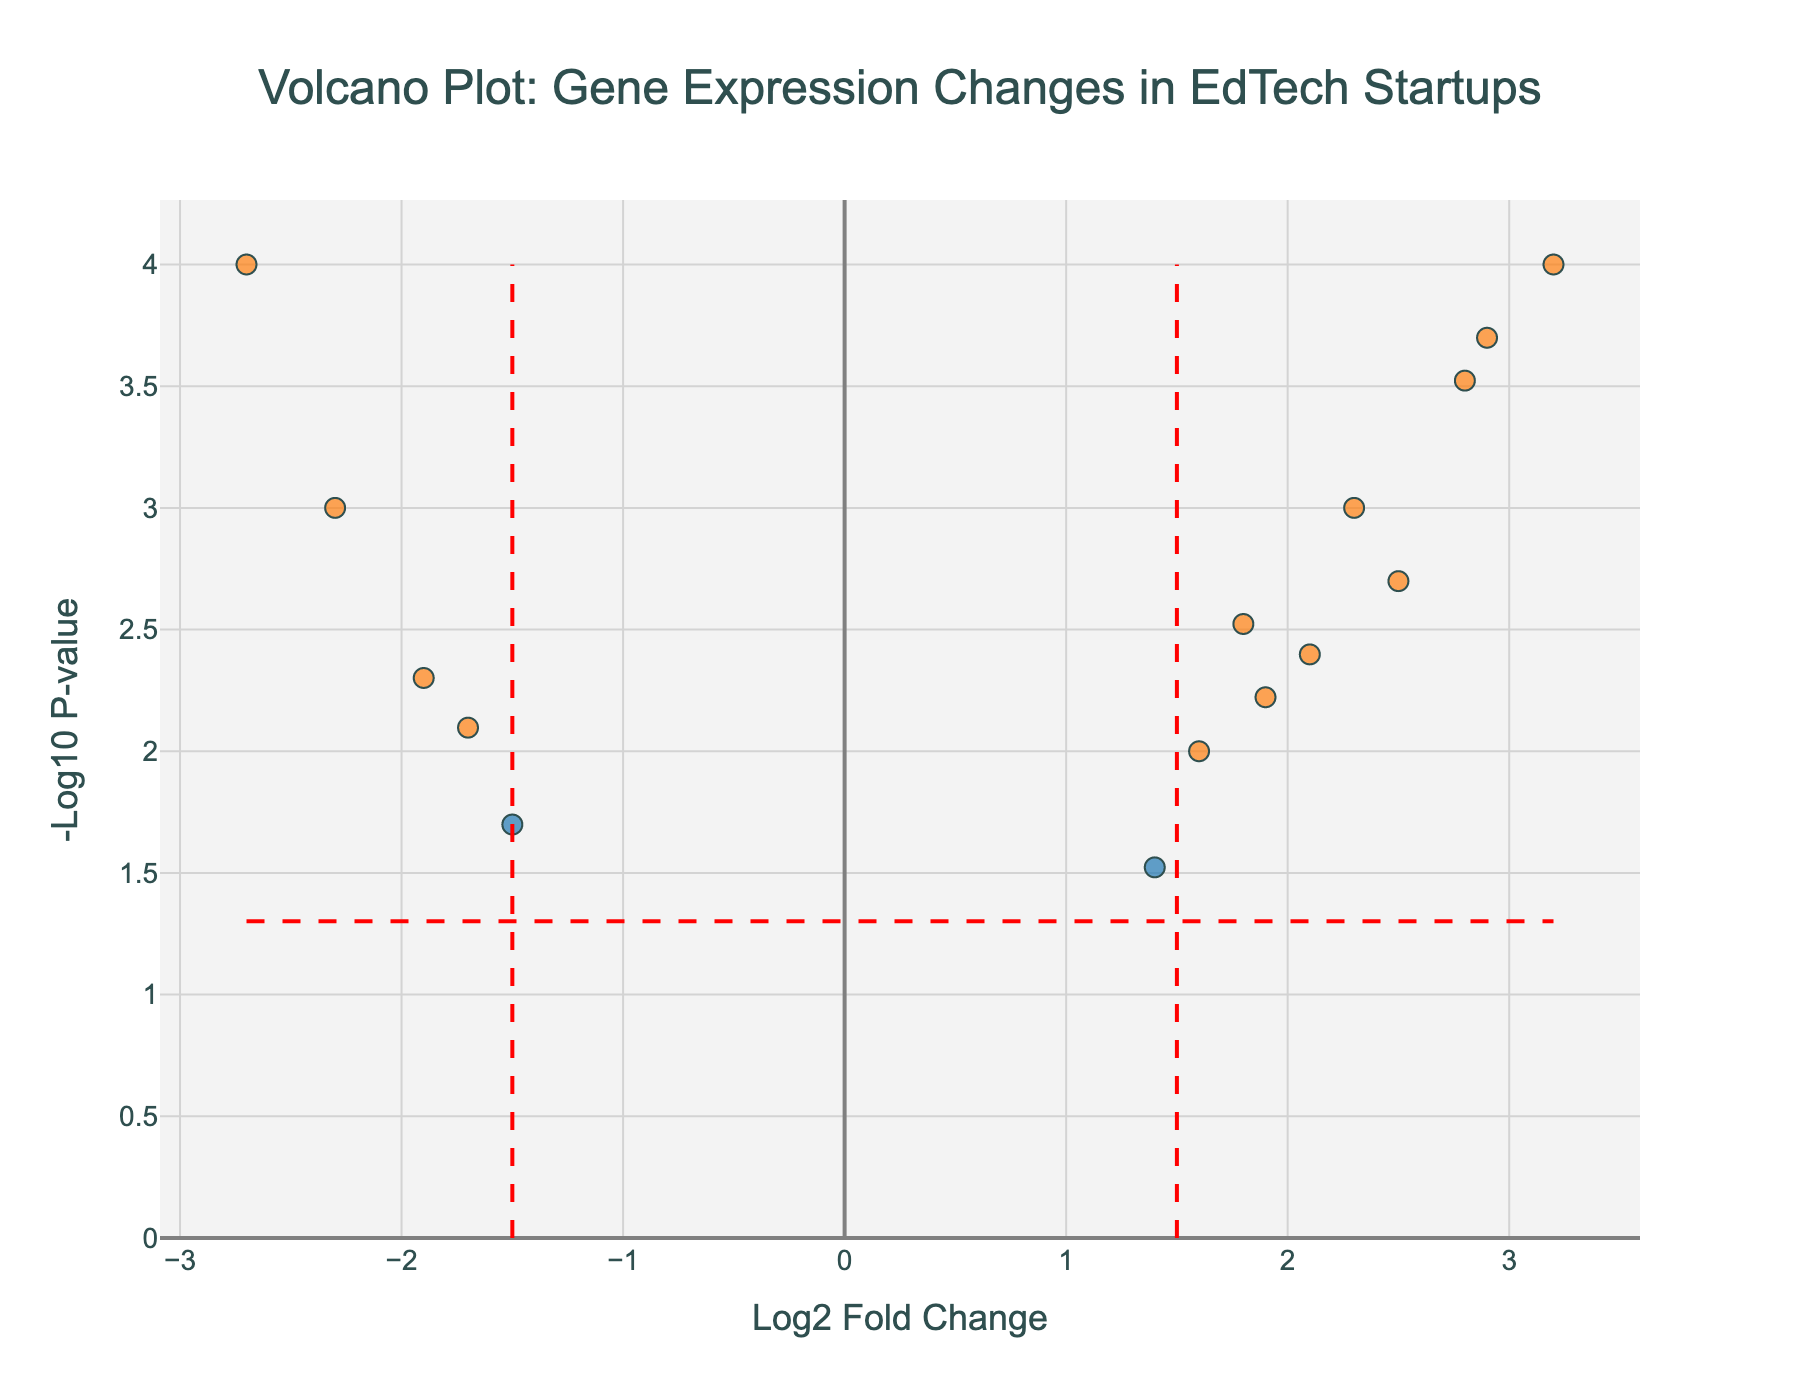What is the title of the figure? The title is shown at the top of the figure in large, prominent text. It reads "Volcano Plot: Gene Expression Changes in EdTech Startups."
Answer: Volcano Plot: Gene Expression Changes in EdTech Startups What do the x-axis and y-axis represent? The x-axis represents "Log2 Fold Change," indicating how much a gene's expression has changed, while the y-axis denotes "-Log10 P-value," representing the significance of the changes.
Answer: x-axis: Log2 Fold Change, y-axis: -Log10 P-value How many genes are significantly up-regulated? Significant up-regulation means a considerable positive Log2 Fold Change and a p-value meeting the significance threshold. Look at the dots on the right side of the plot, colored differently due to a high fold change and low p-value, beyond the threshold lines. There are 7 such genes (STARTUP2, ADMIN3, FUNDING4, GROWTH7, TECH9, EFFECT12, SCALE14).
Answer: 7 Which gene has the most significant up-regulation? Look for the gene with the highest Log2 Fold Change and the lowest p-value among the significantly up-regulated genes. ADMIN3 is the farthest to the right and highest in the plot, indicating the most significant up-regulation.
Answer: ADMIN3 What is the significance threshold for p-value? Check the horizontal red dashed line indicating the common significance threshold for p-values. The value where this line is placed reads -Log10 P-value = 1.3, which equates to a p-value of 0.05.
Answer: 0.05 Which significantly down-regulated gene has the lowest p-value? Examine the significantly down-regulated genes (left of the vertical threshold and below the horizontal threshold). MANAGE10 has the highest -Log10 P-value among them, indicating the lowest p-value.
Answer: MANAGE10 Are there any genes that are not significantly regulated but have high log2 fold changes? Identify genes falling outside the "Significant" category with noticeable Log2 Fold Changes but not crossing the significance p-value threshold. There are no such genes, as all significant Log2 Fold Changes occur at significant p-values.
Answer: No Which gene is closest to the origin of the plot? Spot the gene nearest the (0,0) point of the plot, indicating the least log2 fold change and highest p-value. LEARN6 is at (1.6, 2.00), the closest point on the plot.
Answer: LEARN6 How does the color coding differentiate between significant and non-significant genes? The plot utilizes two colors; one represents "Not Significant" genes with colors cooler and the other vibrant color for "Significant" genes, according to the custom color scale. Genes beyond threshold lines are significantly different.
Answer: Cooler colors for Not Significant, Vibrant colors for Significant 